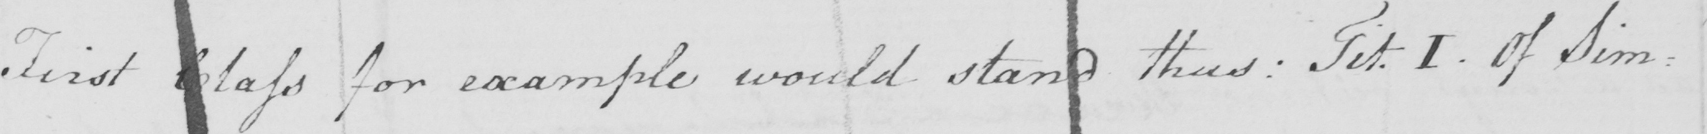Please provide the text content of this handwritten line. First Class for example would stand thus :  Tit . I . Of Sim= 